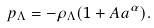<formula> <loc_0><loc_0><loc_500><loc_500>p _ { \Lambda } = - \rho _ { \Lambda } ( 1 + A a ^ { \alpha } ) .</formula> 